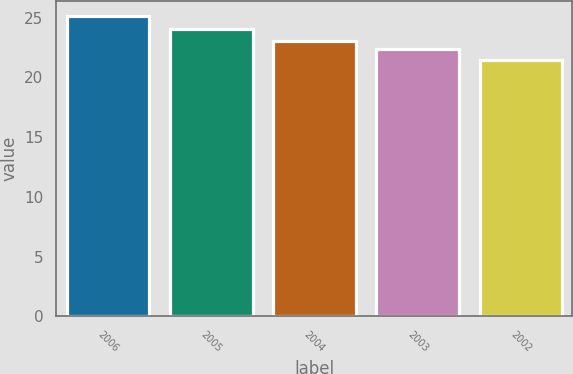Convert chart. <chart><loc_0><loc_0><loc_500><loc_500><bar_chart><fcel>2006<fcel>2005<fcel>2004<fcel>2003<fcel>2002<nl><fcel>25.17<fcel>24.04<fcel>23.08<fcel>22.35<fcel>21.46<nl></chart> 